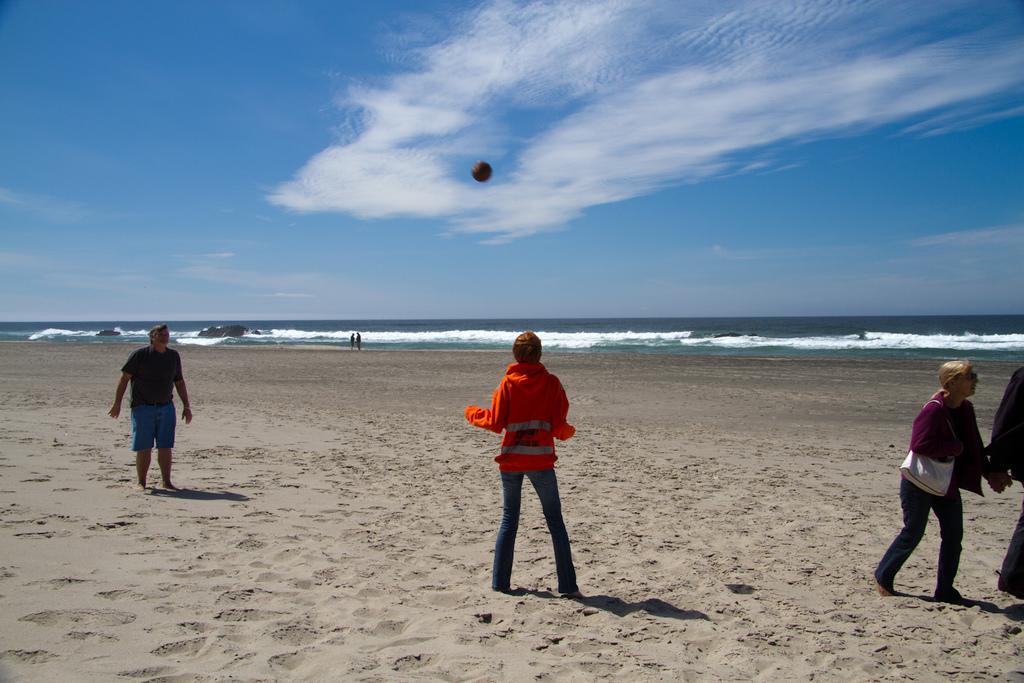Please provide a concise description of this image. This image is clicked near the image. At the bottom, there is sand. In the background, there are waves in the sky. There are few people playing with the ball. At the top, there is a sky. 